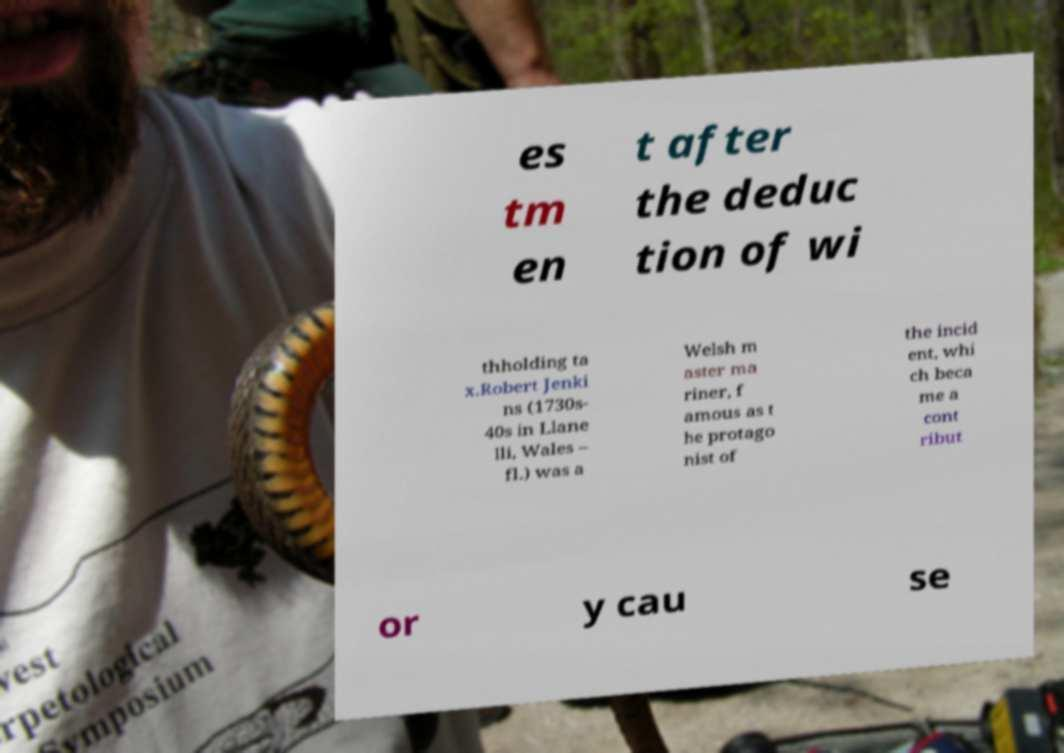Could you assist in decoding the text presented in this image and type it out clearly? es tm en t after the deduc tion of wi thholding ta x.Robert Jenki ns (1730s- 40s in Llane lli, Wales – fl.) was a Welsh m aster ma riner, f amous as t he protago nist of the incid ent, whi ch beca me a cont ribut or y cau se 